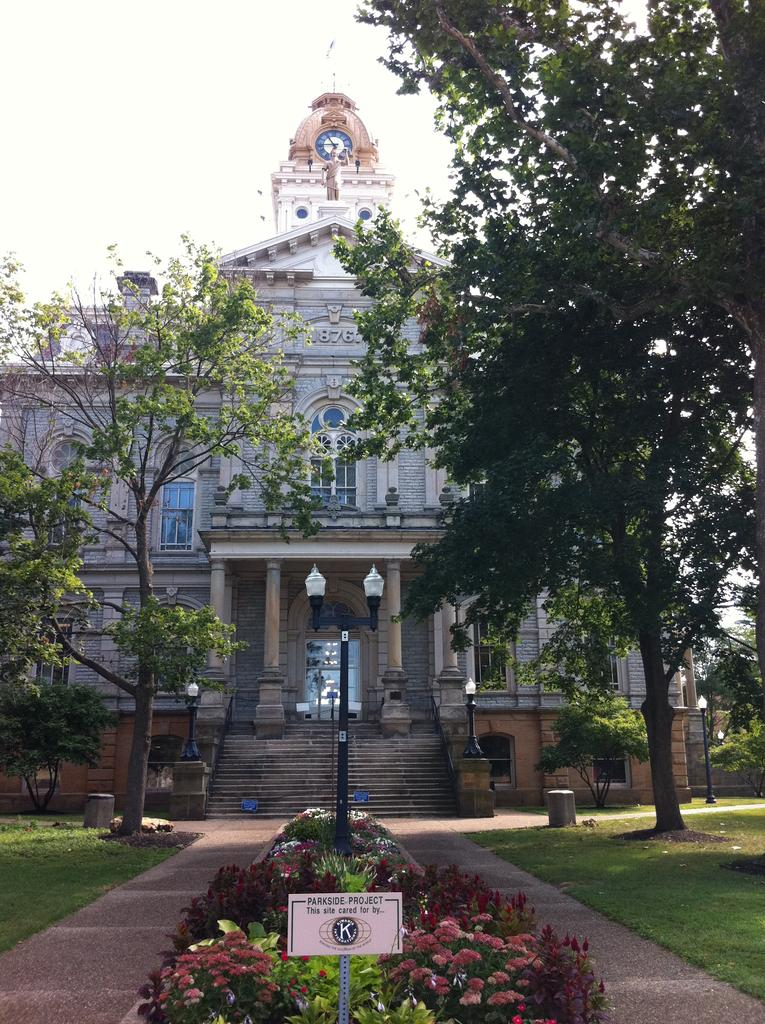<image>
Present a compact description of the photo's key features. A lovely bulding with a sign that says the Parkside Project is cared for by the Kiwanias club. 